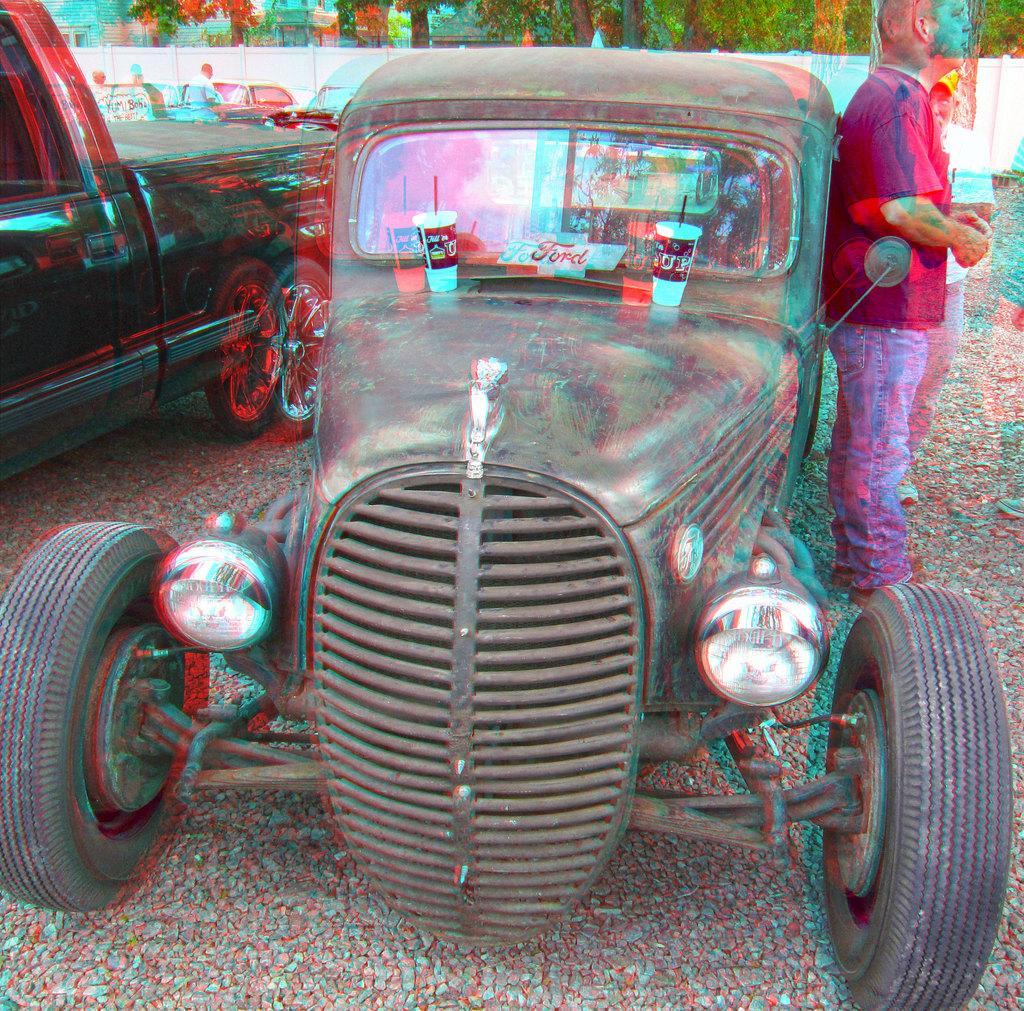Can you describe this image briefly? There is a person standing, near a vehicle, on which, there are two glasses arranged on the road. Beside him, there is another person standing on the road. Beside this vehicle, there are other vehicles and persons standing on the road. In the background, there is a white wall, there are trees and other objects. 